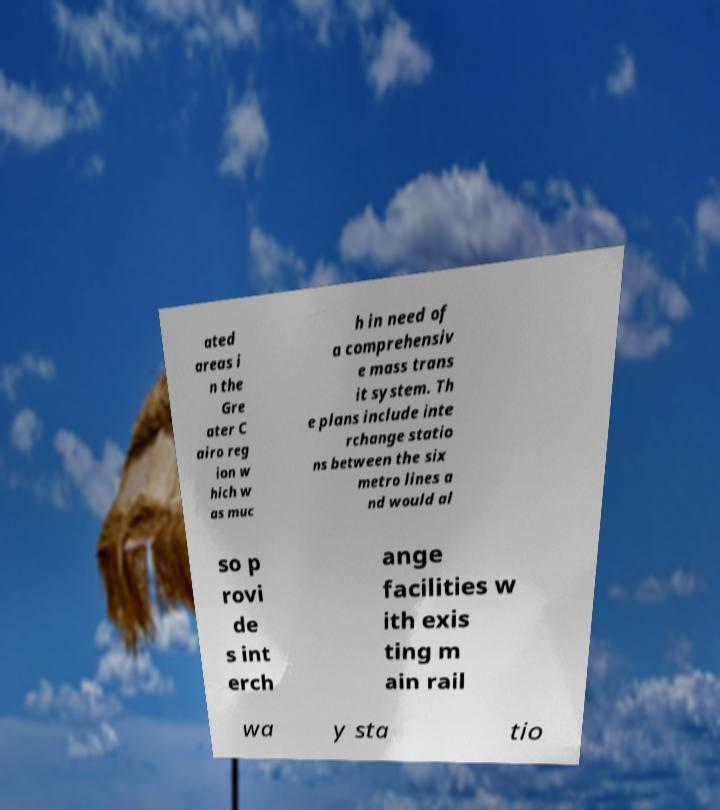There's text embedded in this image that I need extracted. Can you transcribe it verbatim? ated areas i n the Gre ater C airo reg ion w hich w as muc h in need of a comprehensiv e mass trans it system. Th e plans include inte rchange statio ns between the six metro lines a nd would al so p rovi de s int erch ange facilities w ith exis ting m ain rail wa y sta tio 